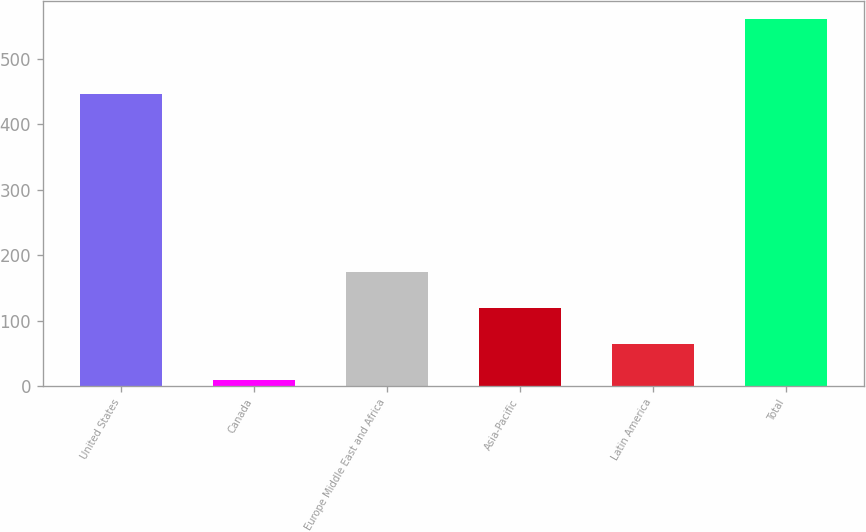<chart> <loc_0><loc_0><loc_500><loc_500><bar_chart><fcel>United States<fcel>Canada<fcel>Europe Middle East and Africa<fcel>Asia-Pacific<fcel>Latin America<fcel>Total<nl><fcel>446.1<fcel>9.2<fcel>174.86<fcel>119.64<fcel>64.42<fcel>561.4<nl></chart> 